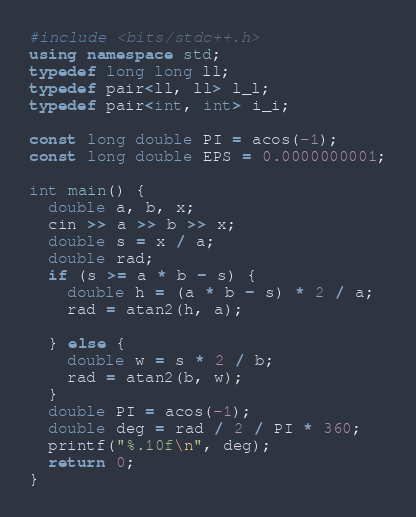Convert code to text. <code><loc_0><loc_0><loc_500><loc_500><_C++_>#include <bits/stdc++.h>
using namespace std;
typedef long long ll;
typedef pair<ll, ll> l_l;
typedef pair<int, int> i_i;

const long double PI = acos(-1);
const long double EPS = 0.0000000001;

int main() {
  double a, b, x;
  cin >> a >> b >> x;
  double s = x / a;
  double rad;
  if (s >= a * b - s) {
    double h = (a * b - s) * 2 / a;
    rad = atan2(h, a);

  } else {
    double w = s * 2 / b;
    rad = atan2(b, w);
  }
  double PI = acos(-1);
  double deg = rad / 2 / PI * 360;
  printf("%.10f\n", deg);
  return 0;
}
</code> 